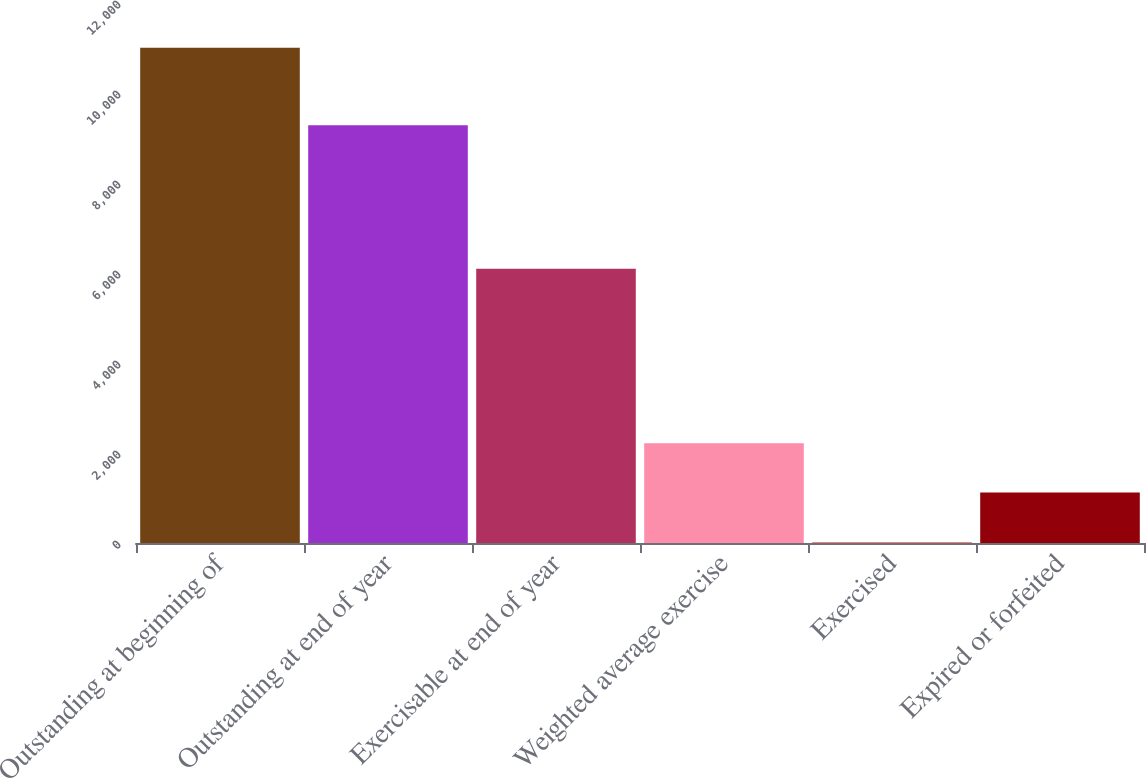Convert chart. <chart><loc_0><loc_0><loc_500><loc_500><bar_chart><fcel>Outstanding at beginning of<fcel>Outstanding at end of year<fcel>Exercisable at end of year<fcel>Weighted average exercise<fcel>Exercised<fcel>Expired or forfeited<nl><fcel>11004<fcel>9283<fcel>6094<fcel>2217.79<fcel>21.23<fcel>1119.51<nl></chart> 